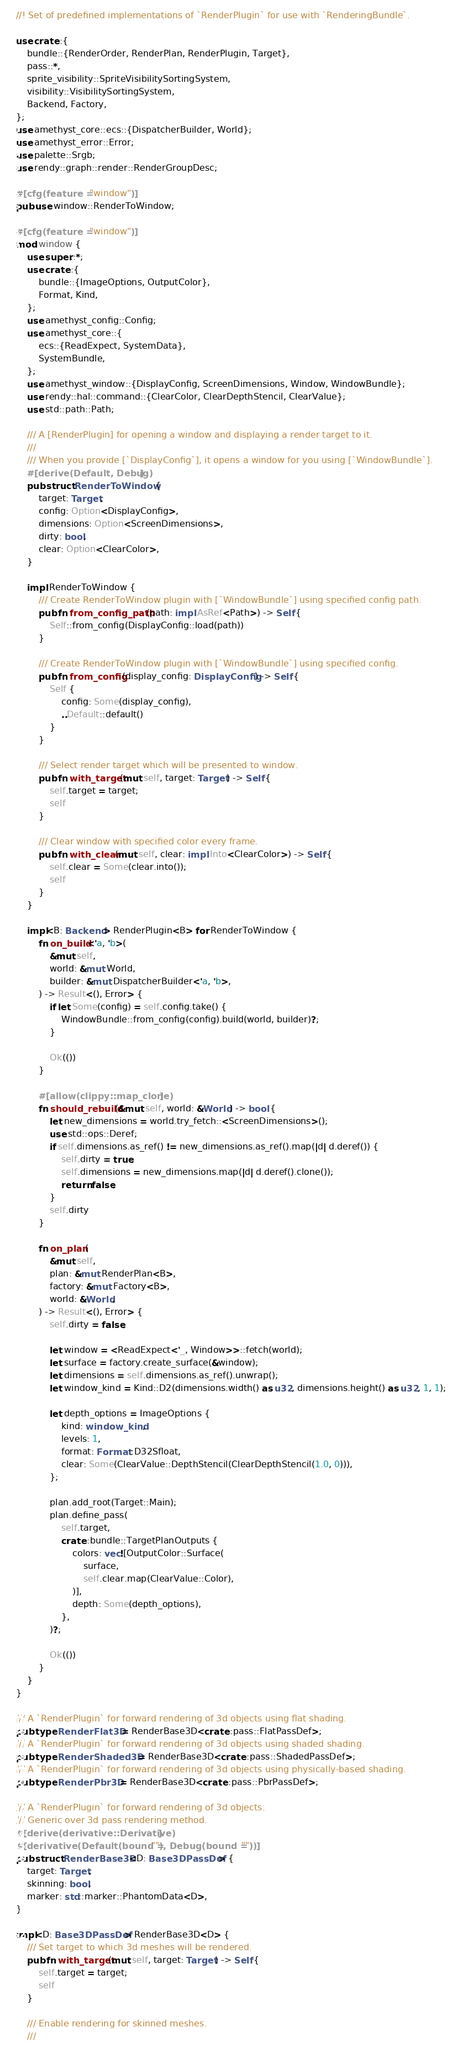<code> <loc_0><loc_0><loc_500><loc_500><_Rust_>//! Set of predefined implementations of `RenderPlugin` for use with `RenderingBundle`.

use crate::{
    bundle::{RenderOrder, RenderPlan, RenderPlugin, Target},
    pass::*,
    sprite_visibility::SpriteVisibilitySortingSystem,
    visibility::VisibilitySortingSystem,
    Backend, Factory,
};
use amethyst_core::ecs::{DispatcherBuilder, World};
use amethyst_error::Error;
use palette::Srgb;
use rendy::graph::render::RenderGroupDesc;

#[cfg(feature = "window")]
pub use window::RenderToWindow;

#[cfg(feature = "window")]
mod window {
    use super::*;
    use crate::{
        bundle::{ImageOptions, OutputColor},
        Format, Kind,
    };
    use amethyst_config::Config;
    use amethyst_core::{
        ecs::{ReadExpect, SystemData},
        SystemBundle,
    };
    use amethyst_window::{DisplayConfig, ScreenDimensions, Window, WindowBundle};
    use rendy::hal::command::{ClearColor, ClearDepthStencil, ClearValue};
    use std::path::Path;

    /// A [RenderPlugin] for opening a window and displaying a render target to it.
    ///
    /// When you provide [`DisplayConfig`], it opens a window for you using [`WindowBundle`].
    #[derive(Default, Debug)]
    pub struct RenderToWindow {
        target: Target,
        config: Option<DisplayConfig>,
        dimensions: Option<ScreenDimensions>,
        dirty: bool,
        clear: Option<ClearColor>,
    }

    impl RenderToWindow {
        /// Create RenderToWindow plugin with [`WindowBundle`] using specified config path.
        pub fn from_config_path(path: impl AsRef<Path>) -> Self {
            Self::from_config(DisplayConfig::load(path))
        }

        /// Create RenderToWindow plugin with [`WindowBundle`] using specified config.
        pub fn from_config(display_config: DisplayConfig) -> Self {
            Self {
                config: Some(display_config),
                ..Default::default()
            }
        }

        /// Select render target which will be presented to window.
        pub fn with_target(mut self, target: Target) -> Self {
            self.target = target;
            self
        }

        /// Clear window with specified color every frame.
        pub fn with_clear(mut self, clear: impl Into<ClearColor>) -> Self {
            self.clear = Some(clear.into());
            self
        }
    }

    impl<B: Backend> RenderPlugin<B> for RenderToWindow {
        fn on_build<'a, 'b>(
            &mut self,
            world: &mut World,
            builder: &mut DispatcherBuilder<'a, 'b>,
        ) -> Result<(), Error> {
            if let Some(config) = self.config.take() {
                WindowBundle::from_config(config).build(world, builder)?;
            }

            Ok(())
        }

        #[allow(clippy::map_clone)]
        fn should_rebuild(&mut self, world: &World) -> bool {
            let new_dimensions = world.try_fetch::<ScreenDimensions>();
            use std::ops::Deref;
            if self.dimensions.as_ref() != new_dimensions.as_ref().map(|d| d.deref()) {
                self.dirty = true;
                self.dimensions = new_dimensions.map(|d| d.deref().clone());
                return false;
            }
            self.dirty
        }

        fn on_plan(
            &mut self,
            plan: &mut RenderPlan<B>,
            factory: &mut Factory<B>,
            world: &World,
        ) -> Result<(), Error> {
            self.dirty = false;

            let window = <ReadExpect<'_, Window>>::fetch(world);
            let surface = factory.create_surface(&window);
            let dimensions = self.dimensions.as_ref().unwrap();
            let window_kind = Kind::D2(dimensions.width() as u32, dimensions.height() as u32, 1, 1);

            let depth_options = ImageOptions {
                kind: window_kind,
                levels: 1,
                format: Format::D32Sfloat,
                clear: Some(ClearValue::DepthStencil(ClearDepthStencil(1.0, 0))),
            };

            plan.add_root(Target::Main);
            plan.define_pass(
                self.target,
                crate::bundle::TargetPlanOutputs {
                    colors: vec![OutputColor::Surface(
                        surface,
                        self.clear.map(ClearValue::Color),
                    )],
                    depth: Some(depth_options),
                },
            )?;

            Ok(())
        }
    }
}

/// A `RenderPlugin` for forward rendering of 3d objects using flat shading.
pub type RenderFlat3D = RenderBase3D<crate::pass::FlatPassDef>;
/// A `RenderPlugin` for forward rendering of 3d objects using shaded shading.
pub type RenderShaded3D = RenderBase3D<crate::pass::ShadedPassDef>;
/// A `RenderPlugin` for forward rendering of 3d objects using physically-based shading.
pub type RenderPbr3D = RenderBase3D<crate::pass::PbrPassDef>;

/// A `RenderPlugin` for forward rendering of 3d objects.
/// Generic over 3d pass rendering method.
#[derive(derivative::Derivative)]
#[derivative(Default(bound = ""), Debug(bound = ""))]
pub struct RenderBase3D<D: Base3DPassDef> {
    target: Target,
    skinning: bool,
    marker: std::marker::PhantomData<D>,
}

impl<D: Base3DPassDef> RenderBase3D<D> {
    /// Set target to which 3d meshes will be rendered.
    pub fn with_target(mut self, target: Target) -> Self {
        self.target = target;
        self
    }

    /// Enable rendering for skinned meshes.
    ///</code> 